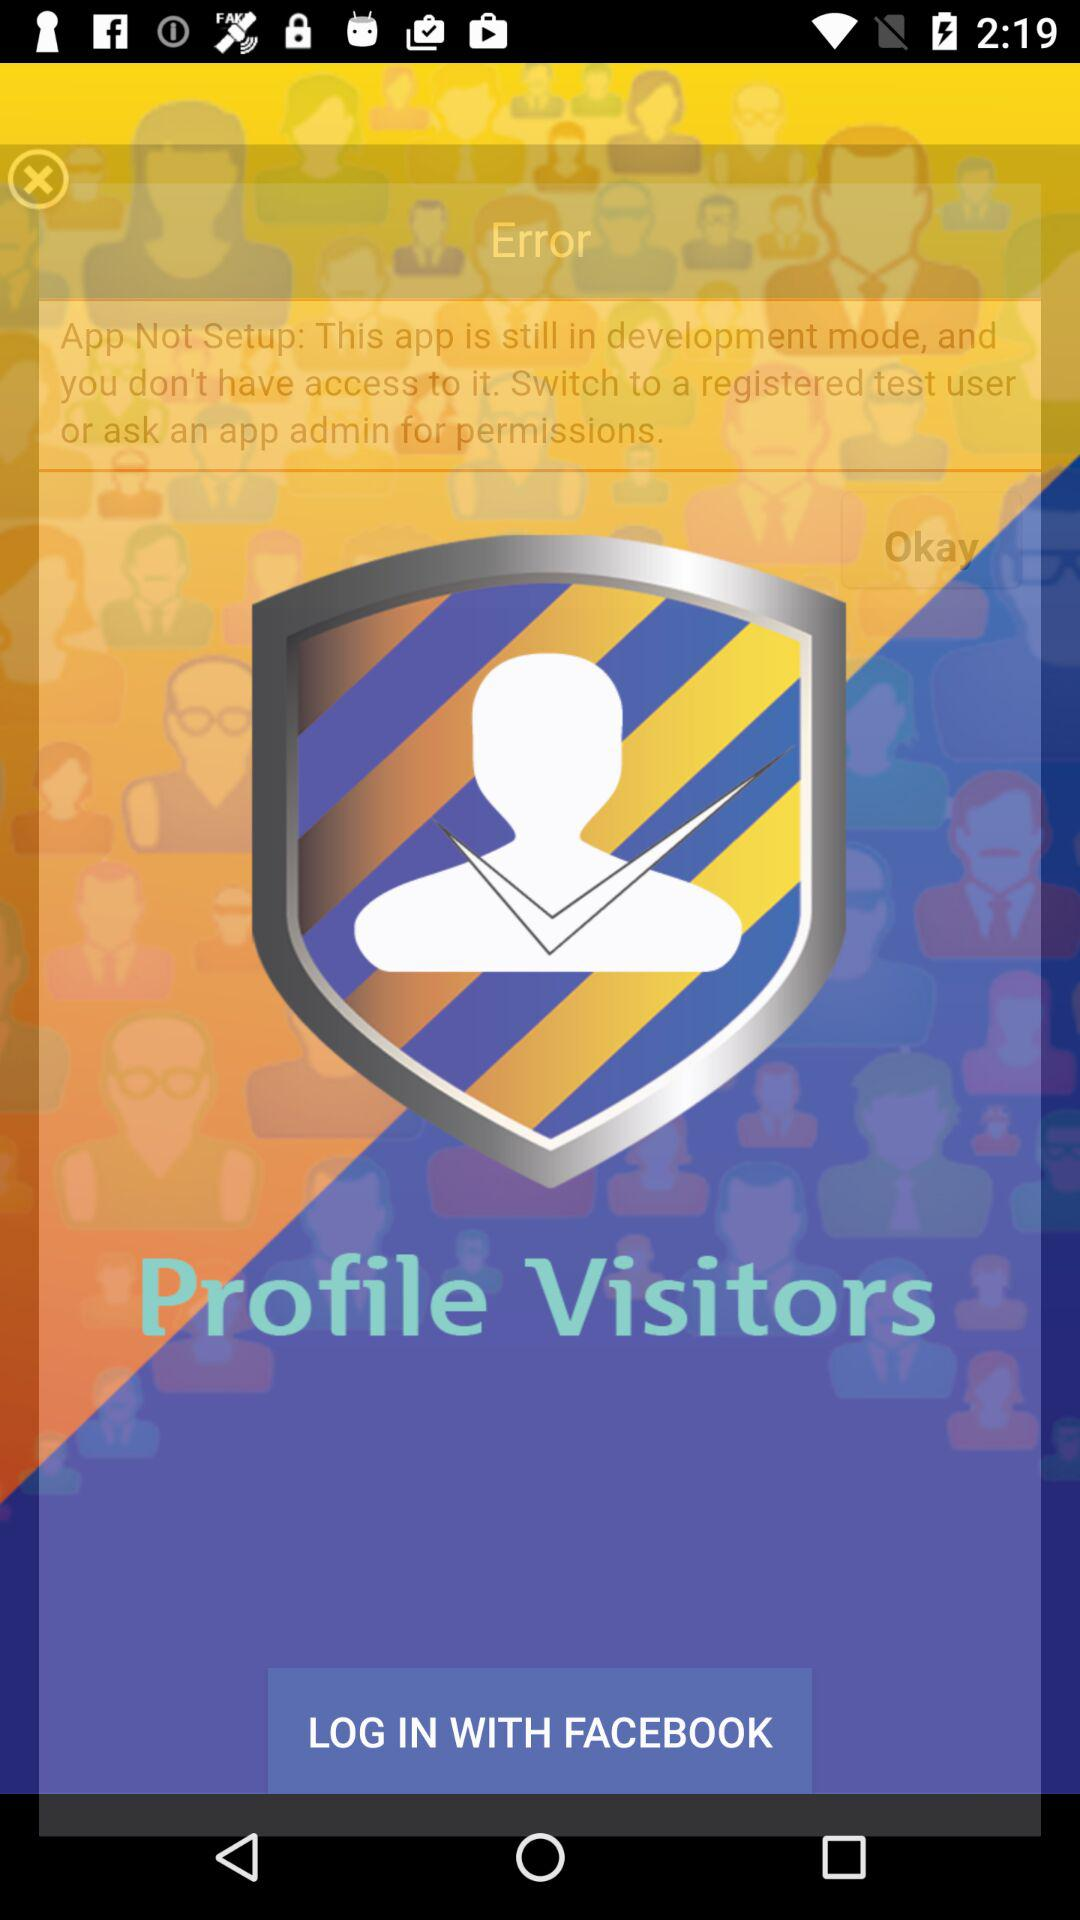How many profile visitors are there?
When the provided information is insufficient, respond with <no answer>. <no answer> 